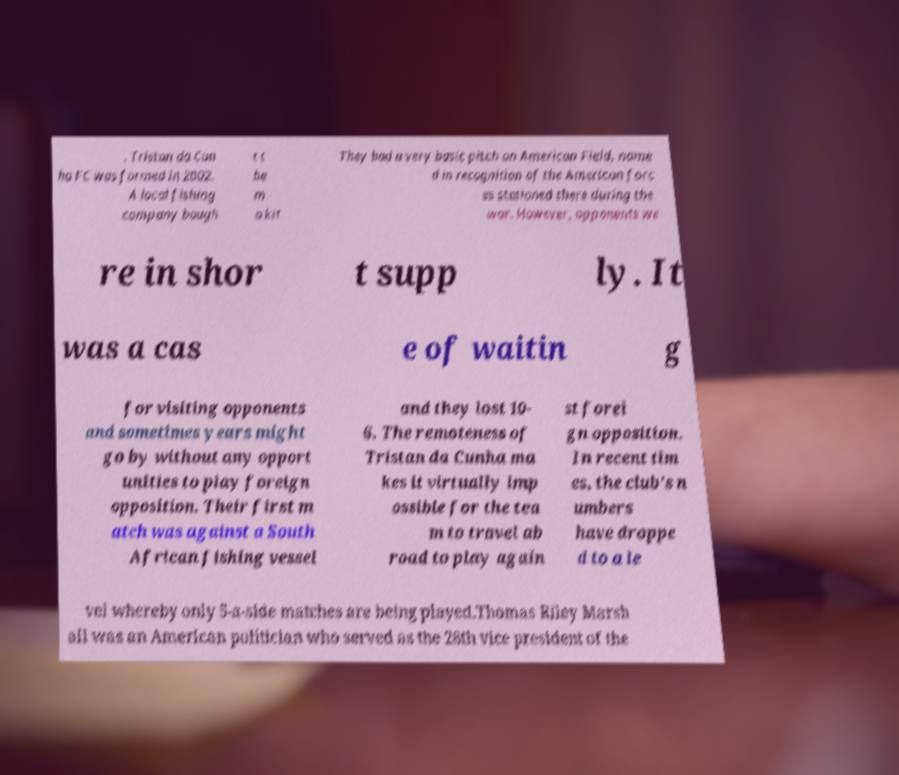Could you extract and type out the text from this image? . Tristan da Cun ha FC was formed in 2002. A local fishing company bough t t he m a kit They had a very basic pitch on American Field, name d in recognition of the American forc es stationed there during the war. However, opponents we re in shor t supp ly. It was a cas e of waitin g for visiting opponents and sometimes years might go by without any opport unities to play foreign opposition. Their first m atch was against a South African fishing vessel and they lost 10- 6. The remoteness of Tristan da Cunha ma kes it virtually imp ossible for the tea m to travel ab road to play again st forei gn opposition. In recent tim es, the club’s n umbers have droppe d to a le vel whereby only 5-a-side matches are being played.Thomas Riley Marsh all was an American politician who served as the 28th vice president of the 